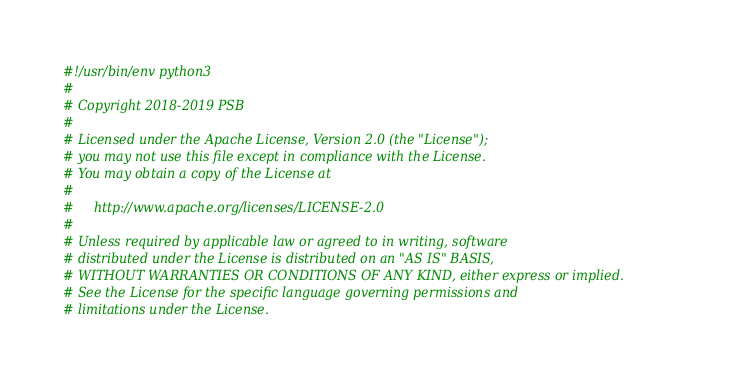Convert code to text. <code><loc_0><loc_0><loc_500><loc_500><_Python_>#!/usr/bin/env python3
#
# Copyright 2018-2019 PSB
#
# Licensed under the Apache License, Version 2.0 (the "License");
# you may not use this file except in compliance with the License.
# You may obtain a copy of the License at
#
#     http://www.apache.org/licenses/LICENSE-2.0
#
# Unless required by applicable law or agreed to in writing, software
# distributed under the License is distributed on an "AS IS" BASIS,
# WITHOUT WARRANTIES OR CONDITIONS OF ANY KIND, either express or implied.
# See the License for the specific language governing permissions and
# limitations under the License.</code> 